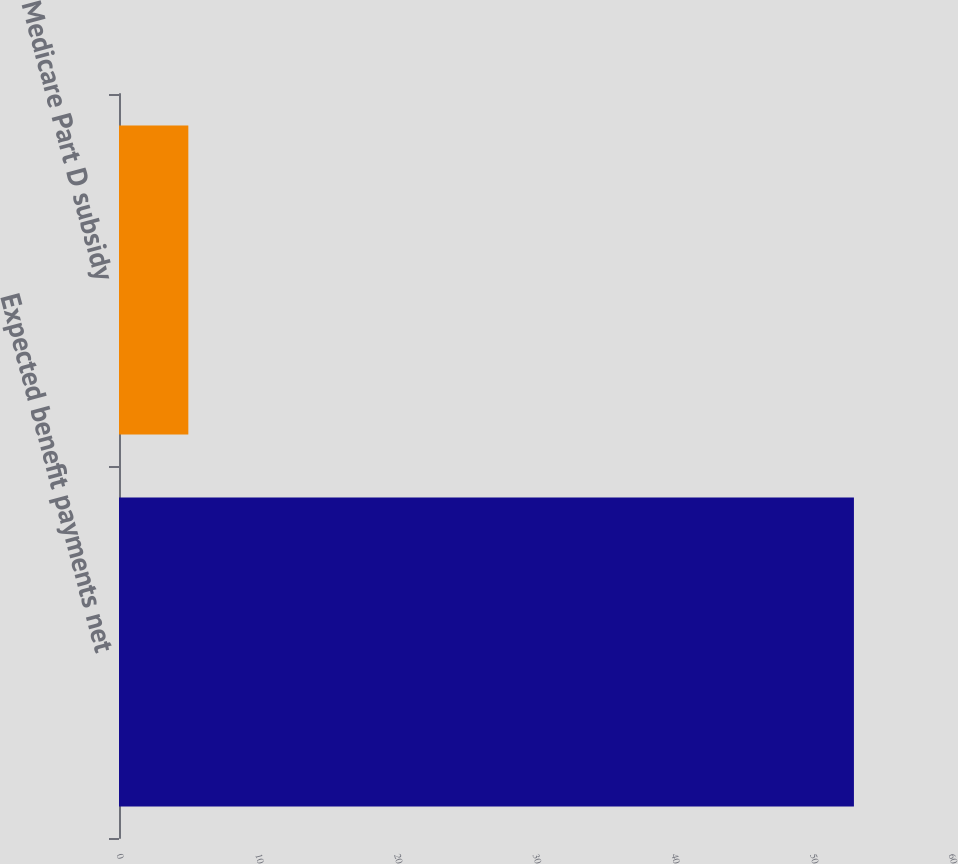Convert chart. <chart><loc_0><loc_0><loc_500><loc_500><bar_chart><fcel>Expected benefit payments net<fcel>Medicare Part D subsidy<nl><fcel>53<fcel>5<nl></chart> 